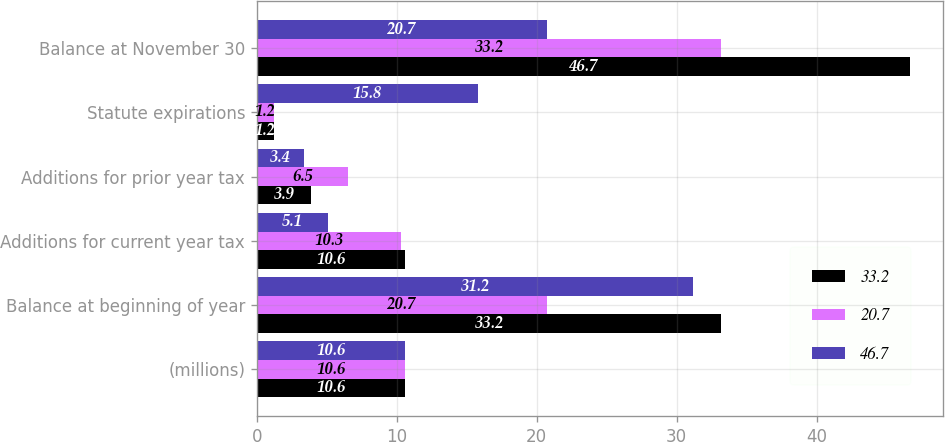Convert chart to OTSL. <chart><loc_0><loc_0><loc_500><loc_500><stacked_bar_chart><ecel><fcel>(millions)<fcel>Balance at beginning of year<fcel>Additions for current year tax<fcel>Additions for prior year tax<fcel>Statute expirations<fcel>Balance at November 30<nl><fcel>33.2<fcel>10.6<fcel>33.2<fcel>10.6<fcel>3.9<fcel>1.2<fcel>46.7<nl><fcel>20.7<fcel>10.6<fcel>20.7<fcel>10.3<fcel>6.5<fcel>1.2<fcel>33.2<nl><fcel>46.7<fcel>10.6<fcel>31.2<fcel>5.1<fcel>3.4<fcel>15.8<fcel>20.7<nl></chart> 